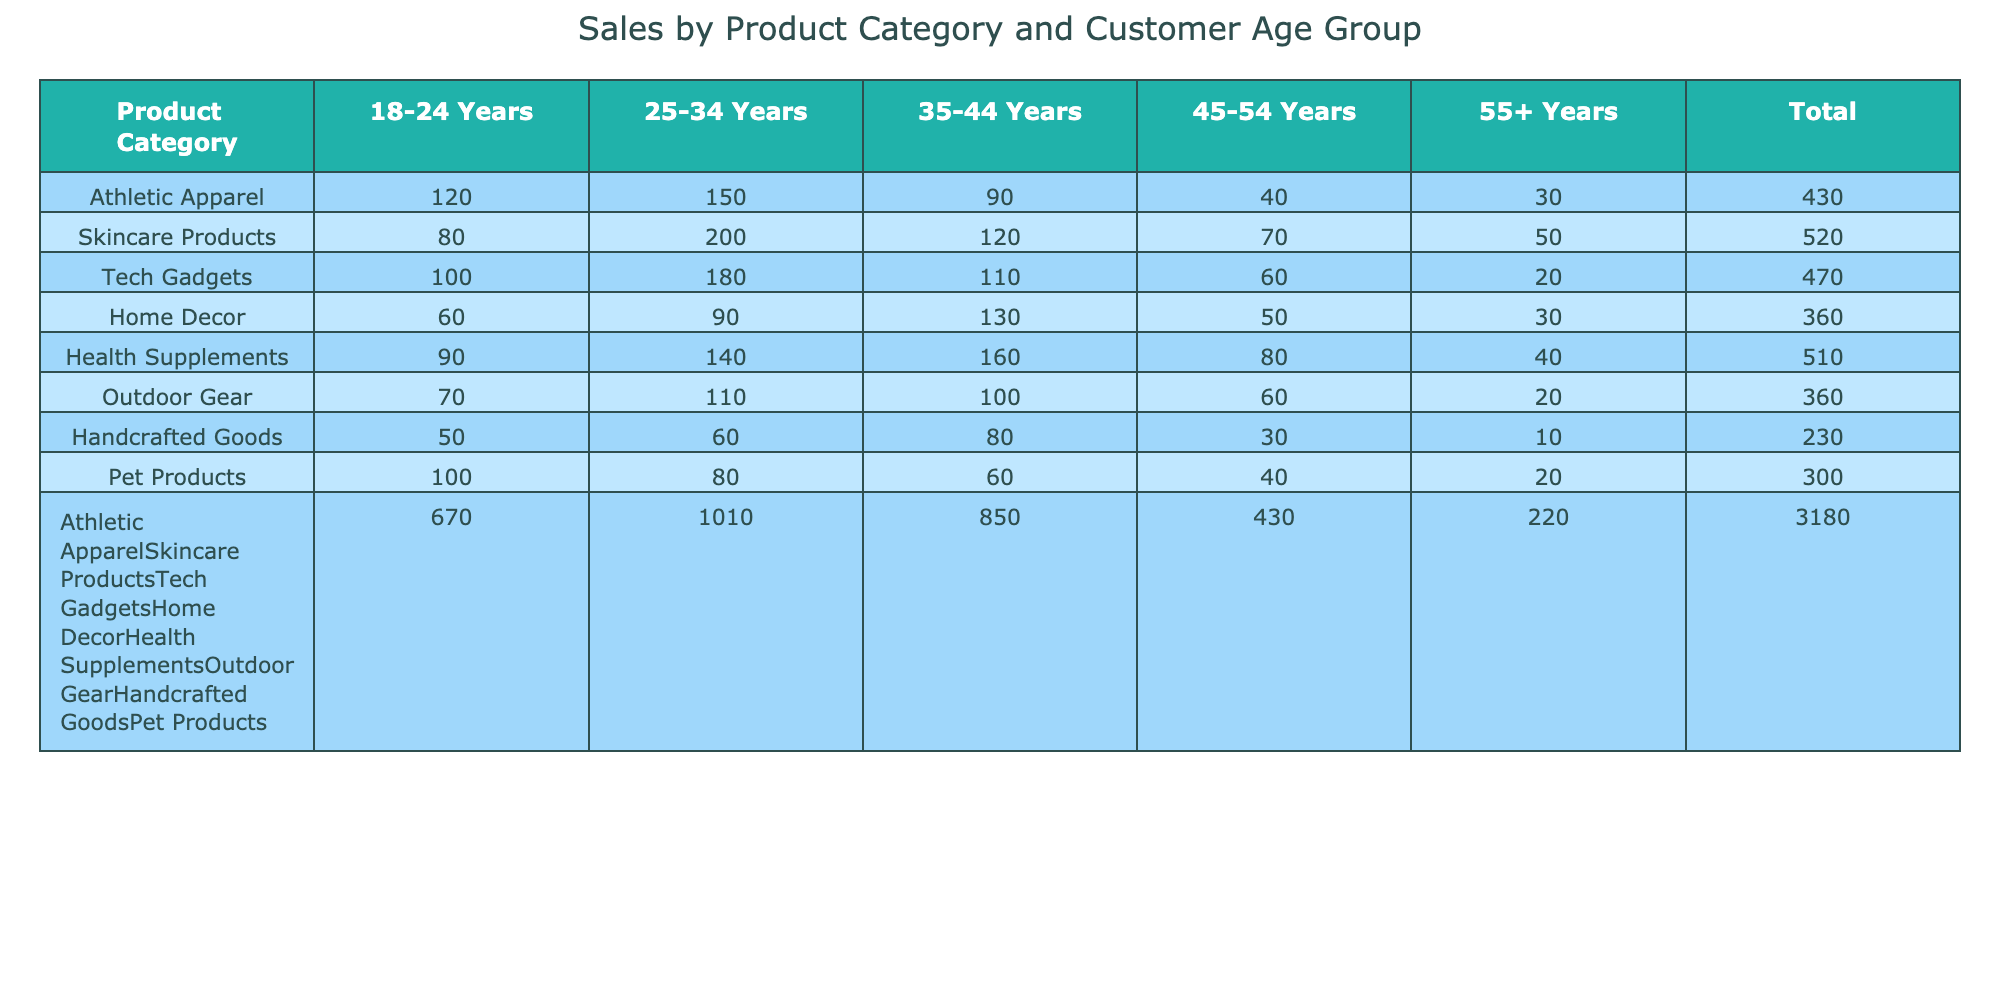What is the total sales for Athletic Apparel? To find the total sales for Athletic Apparel, look at the total column in the row corresponding to Athletic Apparel. The total sales value there is 120 + 150 + 90 + 40 + 30 = 430.
Answer: 430 Which age group spent the most on Skincare Products? For Skincare Products, review the numbers across age groups: 80 for 18-24 years, 200 for 25-34 years, 120 for 35-44 years, 70 for 45-54 years, and 50 for 55+ years. The highest value is in the 25-34 years age group with 200.
Answer: 25-34 Years How many sales were recorded for Outdoor Gear among customers aged 35-44? Look at the row for Outdoor Gear and find the value under the 35-44 years column, which is 100.
Answer: 100 Did the sales for Health Supplements exceed 400? The total sales for Health Supplements can be calculated by summing the values across all age groups: 90 + 140 + 160 + 80 + 40 = 510. Since 510 is greater than 400, the answer is yes.
Answer: Yes What is the difference in sales between Tech Gadgets and Home Decor for the 45-54 age group? First, find the sales for Tech Gadgets in the 45-54 age group, which is 60. Next, look at Home Decor in the same age group, which is 50. The difference is calculated as 60 - 50 = 10.
Answer: 10 Which product category has the highest total sales? To determine which product category has the highest total sales, compare the total values from the last column: Athletic Apparel (430), Skincare Products (520), Tech Gadgets (580), Home Decor (410), Health Supplements (510), Outdoor Gear (400), Handcrafted Goods (270), and Pet Products (400). The maximum is for Tech Gadgets with 580.
Answer: Tech Gadgets What is the average sales for the 55+ age group across all product categories? To find the average sales for the 55+ age group, first sum the sales in that column: 30 + 50 + 20 + 30 + 40 + 20 + 10 + 20 = 220. There are 8 categories, so the average is 220 / 8 = 27.5.
Answer: 27.5 Is the total sales for Handcrafted Goods lower than the total for Pet Products? Calculate the total sales for Handcrafted Goods: 50 + 60 + 80 + 30 + 10 = 230, and for Pet Products: 100 + 80 + 60 + 40 + 20 = 300. Since 230 is less than 300, the answer is yes.
Answer: Yes How many sales of Health Supplements were made to the 25-34 age group? The value for Health Supplements under the 25-34 years age group is clearly shown as 140.
Answer: 140 